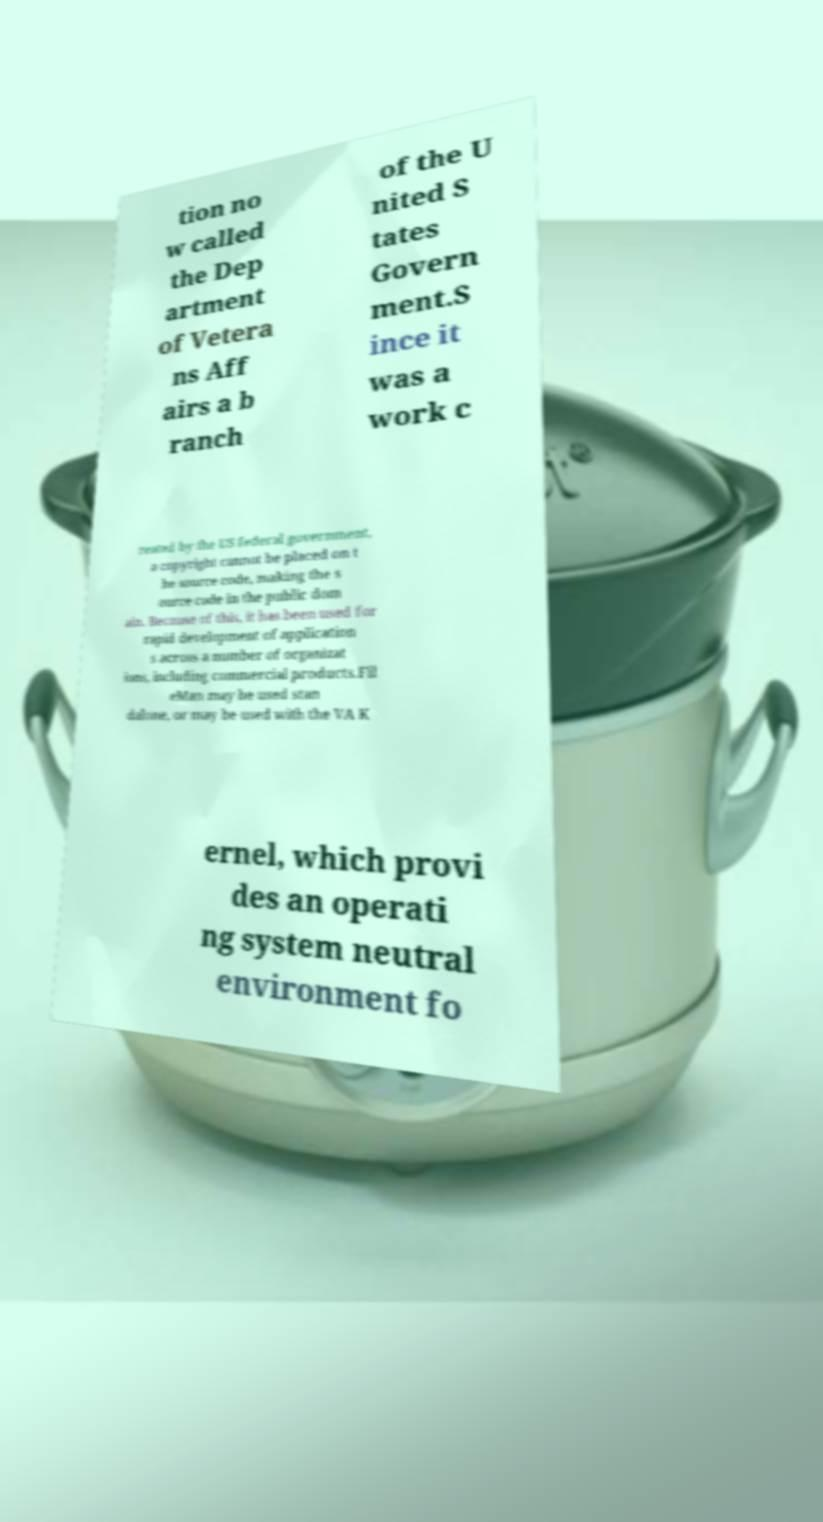For documentation purposes, I need the text within this image transcribed. Could you provide that? tion no w called the Dep artment of Vetera ns Aff airs a b ranch of the U nited S tates Govern ment.S ince it was a work c reated by the US federal government, a copyright cannot be placed on t he source code, making the s ource code in the public dom ain. Because of this, it has been used for rapid development of application s across a number of organizat ions, including commercial products.Fil eMan may be used stan dalone, or may be used with the VA K ernel, which provi des an operati ng system neutral environment fo 